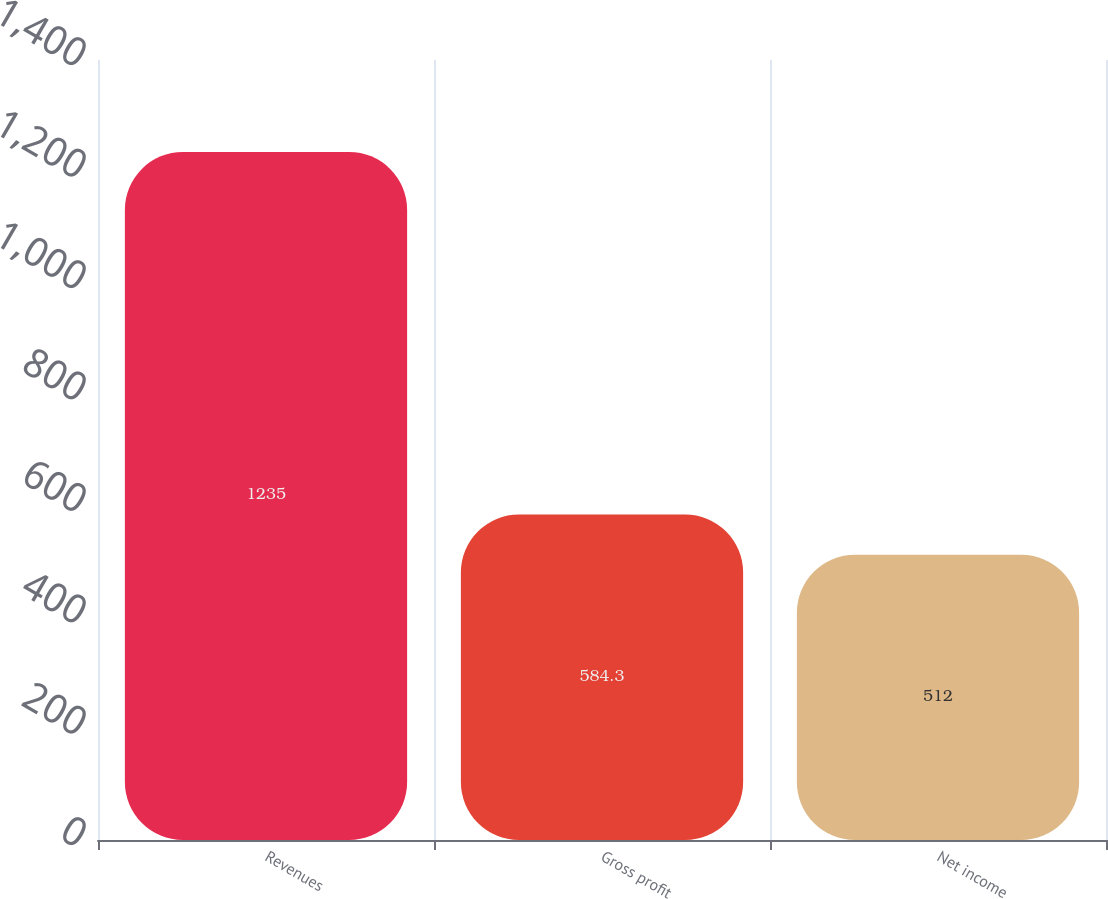Convert chart to OTSL. <chart><loc_0><loc_0><loc_500><loc_500><bar_chart><fcel>Revenues<fcel>Gross profit<fcel>Net income<nl><fcel>1235<fcel>584.3<fcel>512<nl></chart> 